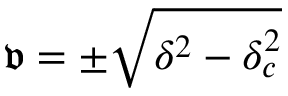<formula> <loc_0><loc_0><loc_500><loc_500>\mathfrak { v } = \pm \sqrt { \delta ^ { 2 } - \delta _ { c } ^ { 2 } }</formula> 